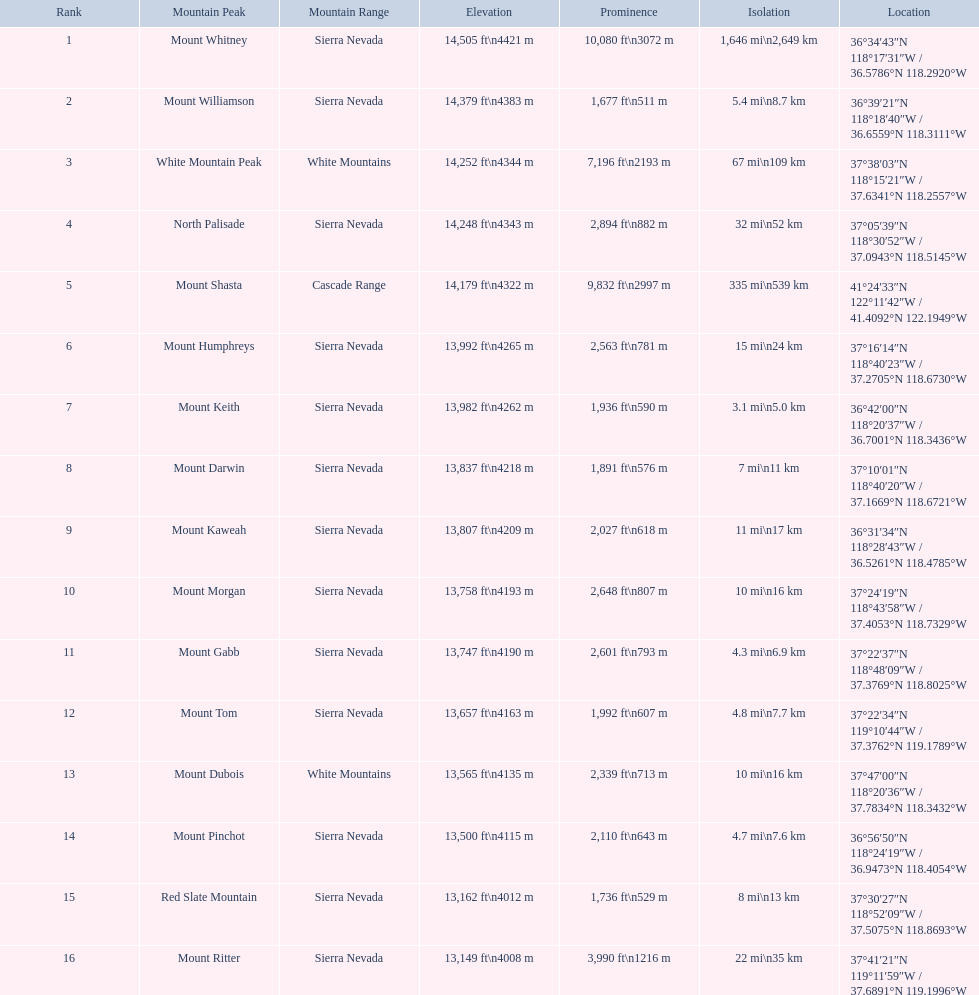What are the recorded elevations? 14,505 ft\n4421 m, 14,379 ft\n4383 m, 14,252 ft\n4344 m, 14,248 ft\n4343 m, 14,179 ft\n4322 m, 13,992 ft\n4265 m, 13,982 ft\n4262 m, 13,837 ft\n4218 m, 13,807 ft\n4209 m, 13,758 ft\n4193 m, 13,747 ft\n4190 m, 13,657 ft\n4163 m, 13,565 ft\n4135 m, 13,500 ft\n4115 m, 13,162 ft\n4012 m, 13,149 ft\n4008 m. Which one is 13,149 feet or lower? 13,149 ft\n4008 m. Which mountain peak is related to that measurement? Mount Ritter. 